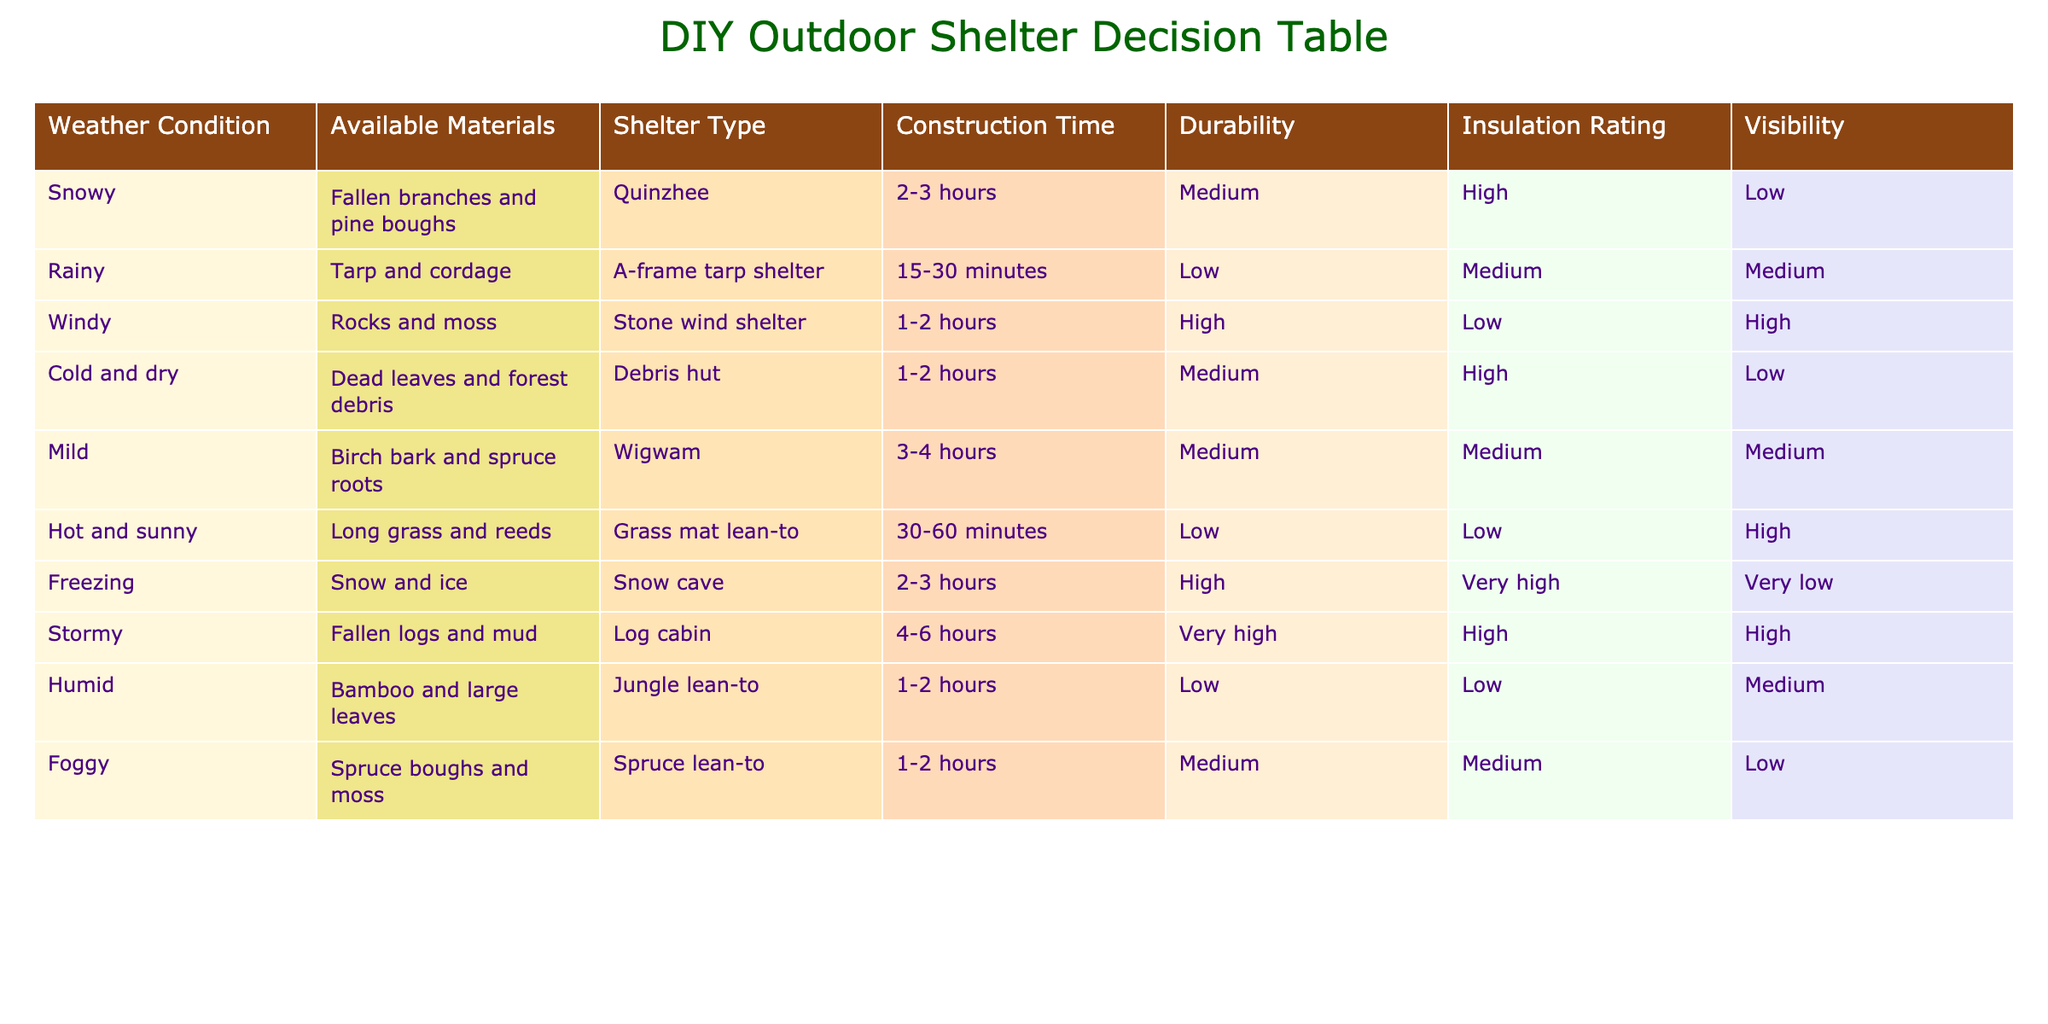What type of shelter should I build if it's snowy and I have fallen branches and pine boughs? The table indicates that in snowy conditions with fallen branches and pine boughs, the ideal shelter type is a Quinzhee.
Answer: Quinzhee Which shelter has the highest durability? The Log cabin has a durability rating of very high, which is the highest value among all shelters listed in the table.
Answer: Log cabin If I want to build a shelter quickly, what would be the best option in rainy weather with a tarp and cordage? In rainy weather with a tarp and cordage, the A-frame tarp shelter can be constructed in 15-30 minutes, making it the quickest option.
Answer: A-frame tarp shelter What’s the average insulation rating of shelters built in cold and dry or snowy conditions? The insulation ratings for snowy (Quinzhee with High) and cold and dry (Debris hut with High) conditions are both High; the average remains High, as both are the same.
Answer: High Is it possible to build a shelter with bamboo and large leaves in foggy conditions? The table does not list bamboo and large leaves as available materials in foggy conditions; thus, it is not possible to build a shelter with those materials there.
Answer: No Which shelter has the lowest insulation rating in hot and sunny weather? The Grass mat lean-to, made of long grass and reeds, has the lowest insulation rating of Low for hot and sunny conditions.
Answer: Grass mat lean-to In stormy weather, what is the shelter type and how long will it take to construct? The Log cabin is the shelter type for stormy weather, requiring 4-6 hours to construct, as indicated in the table.
Answer: Log cabin, 4-6 hours Which weather condition would make the jungle lean-to the most ideal option? The jungle lean-to is most suitable for humid weather, as indicated in the table under that weather condition.
Answer: Humid weather What is the visibility rating of the Quinzhee shelter compared to the Stone wind shelter? The Quinzhee has a visibility rating of Low, while the Stone wind shelter has a visibility rating of High. The Stone wind shelter has better visibility compared to the Quinzhee.
Answer: Stone wind shelter has better visibility 